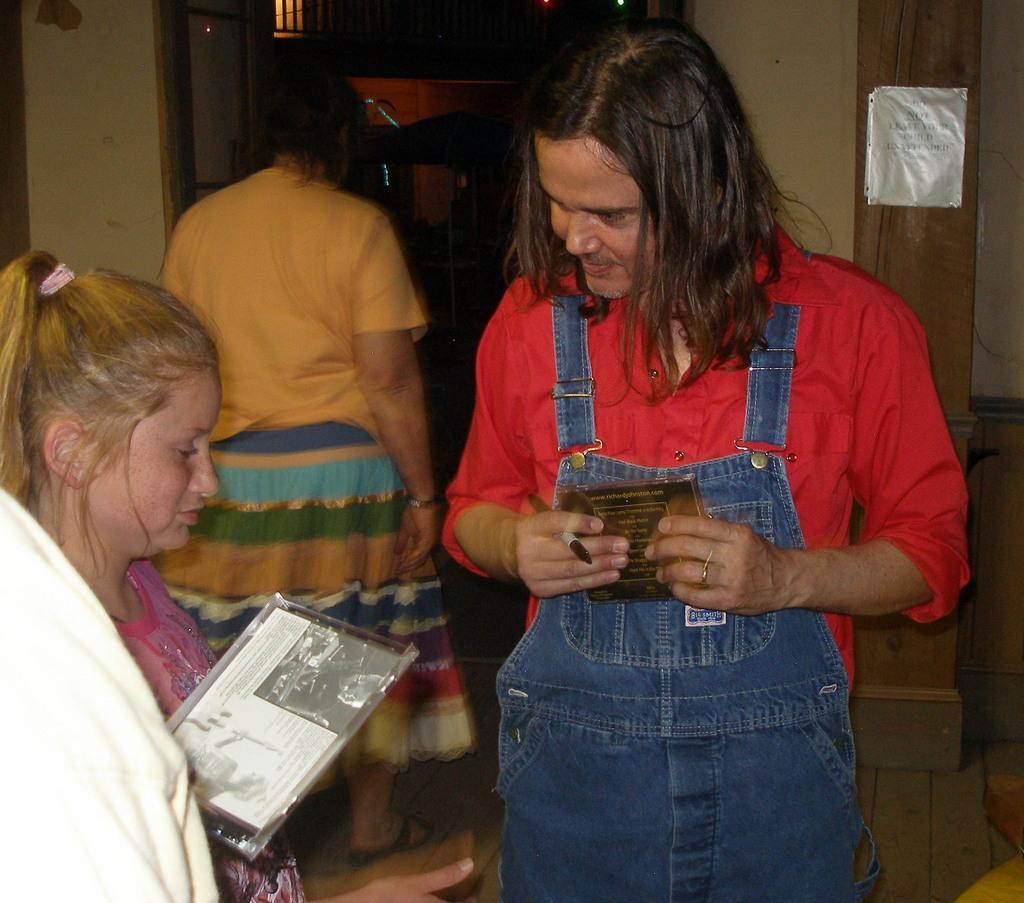In one or two sentences, can you explain what this image depicts? In the image in the center we can see three persons were standing. And in the front,we can see two persons were holding some objects. In the background there is a wall,note and few other objects. 